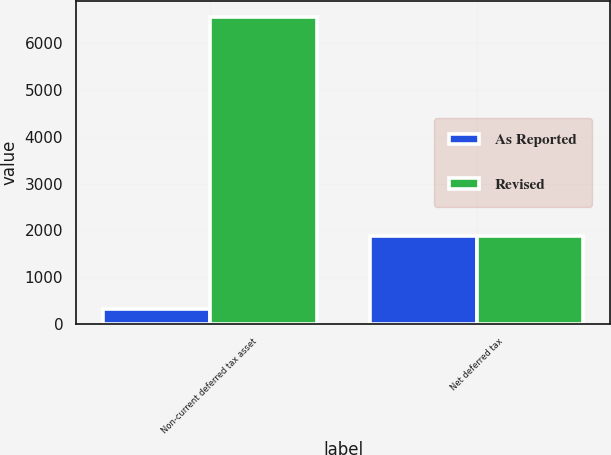<chart> <loc_0><loc_0><loc_500><loc_500><stacked_bar_chart><ecel><fcel>Non-current deferred tax asset<fcel>Net deferred tax<nl><fcel>As Reported<fcel>317<fcel>1890<nl><fcel>Revised<fcel>6576<fcel>1890<nl></chart> 